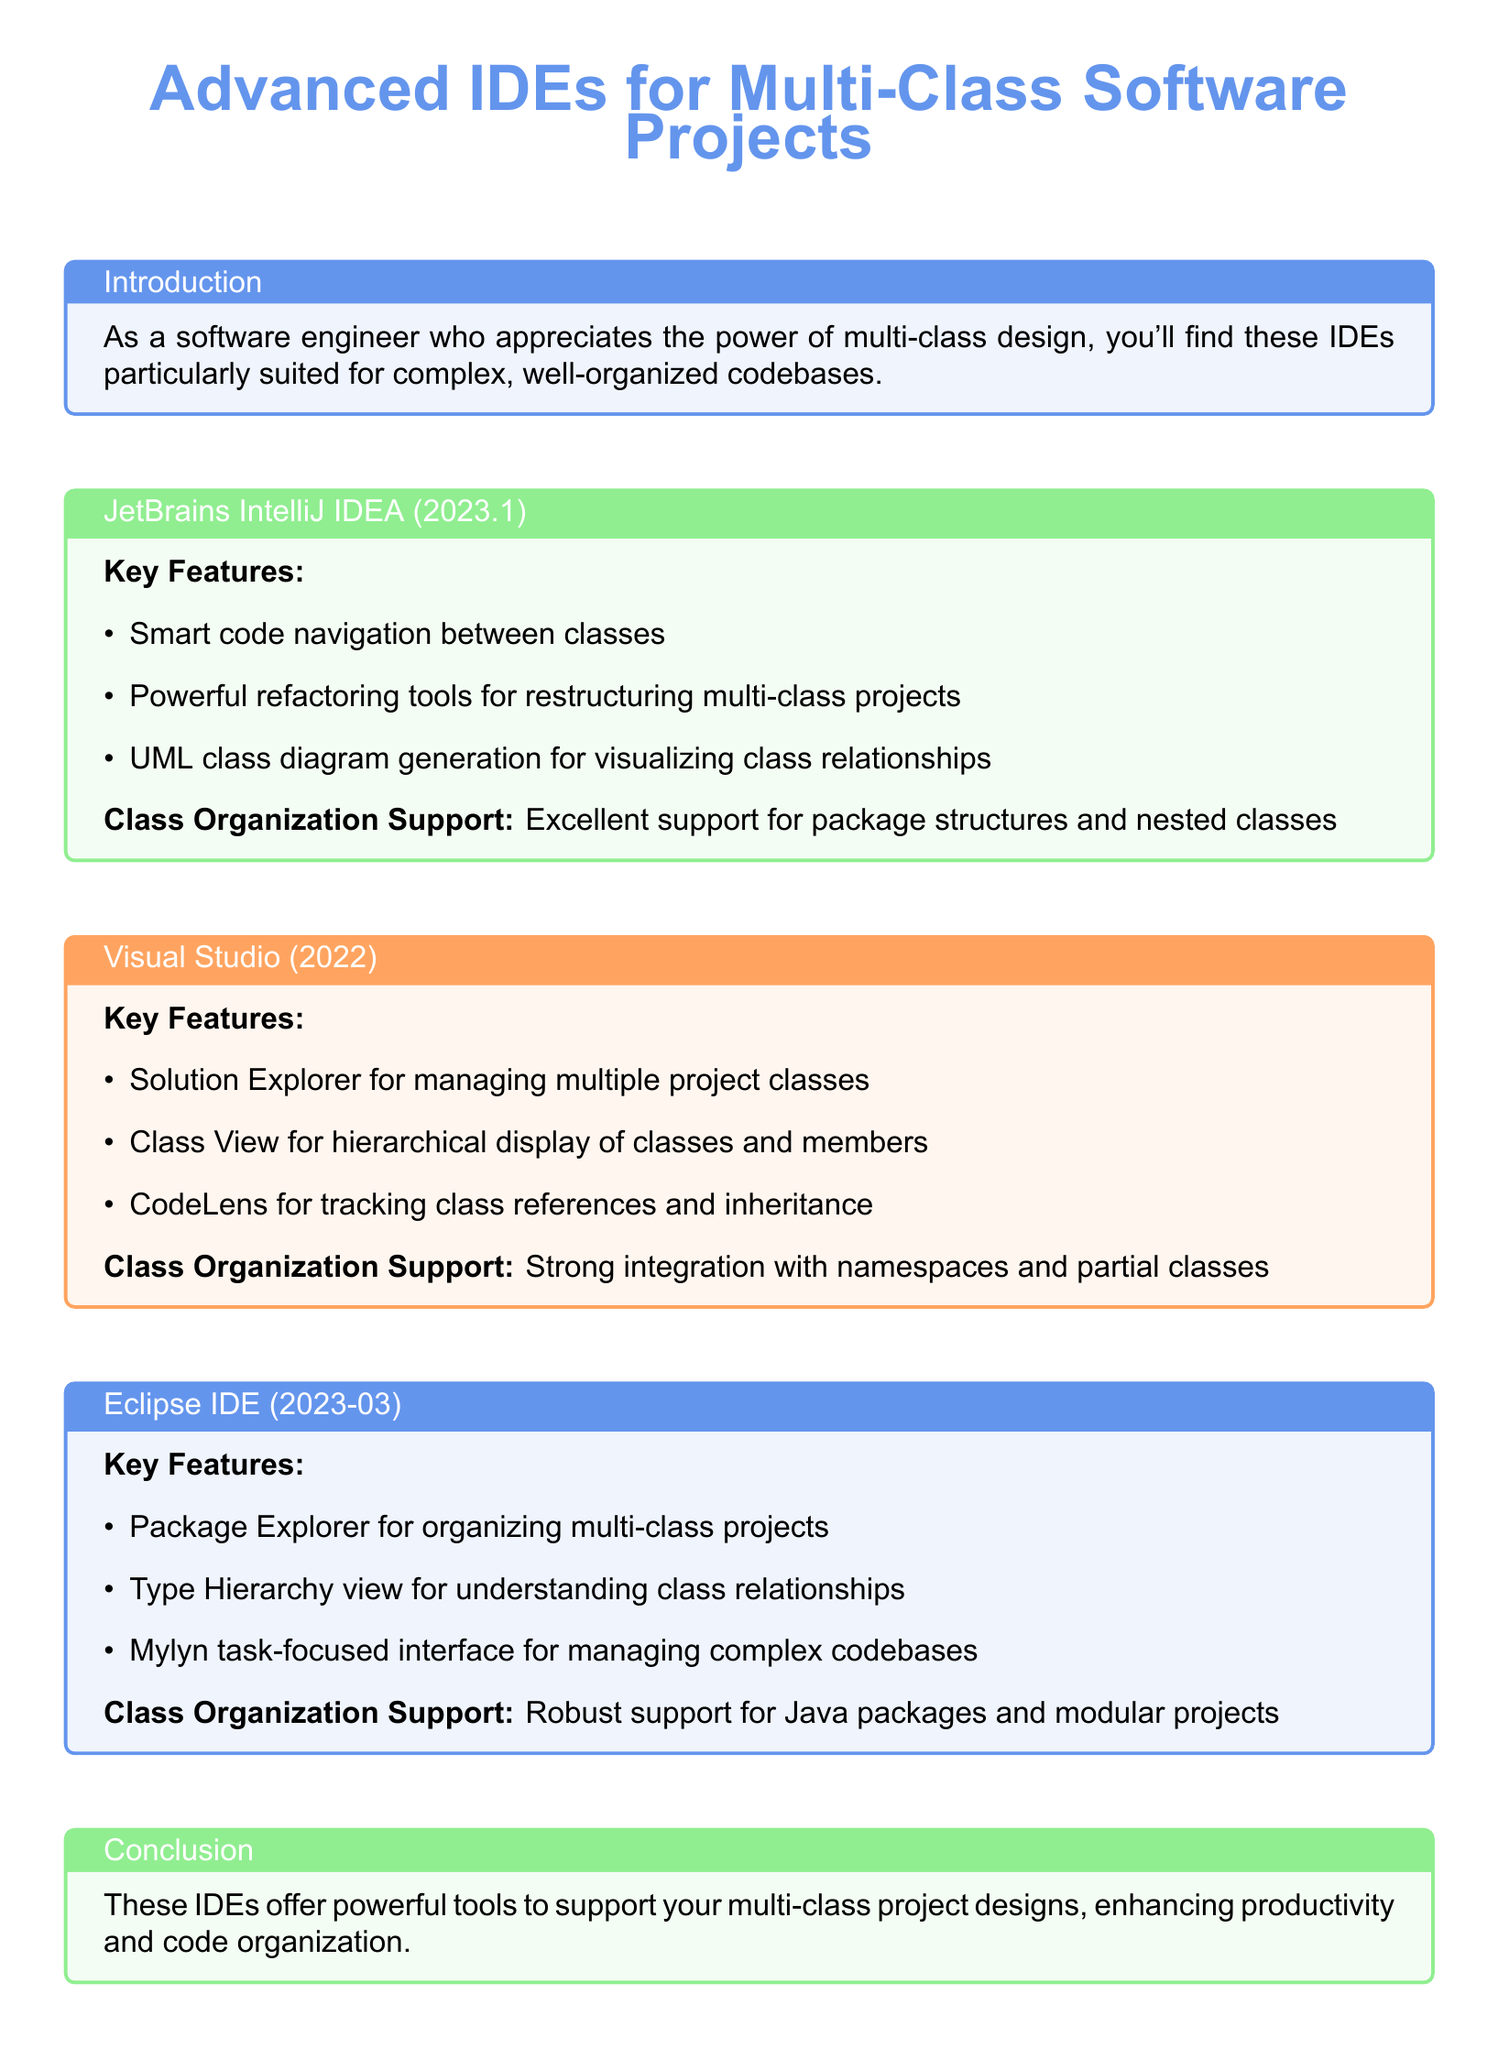What is the title of the document? The title provides the main subject of the catalog, which is centered on IDEs for multi-class projects.
Answer: Advanced IDEs for Multi-Class Software Projects What is one key feature of JetBrains IntelliJ IDEA? This feature highlights its capability to assist in navigating through classes effectively.
Answer: Smart code navigation between classes Which IDE has the feature "Class View"? The Class View is a distinct feature that helps visualize the hierarchy of classes within the IDE.
Answer: Visual Studio What is the organization support type for Eclipse IDE? This describes how the IDE structures support for organizing code effectively, particularly in Java.
Answer: Robust support for Java packages and modular projects How many IDEs are mentioned in the document? This count gives an overview of the different IDEs discussed for multi-class project support.
Answer: Three 